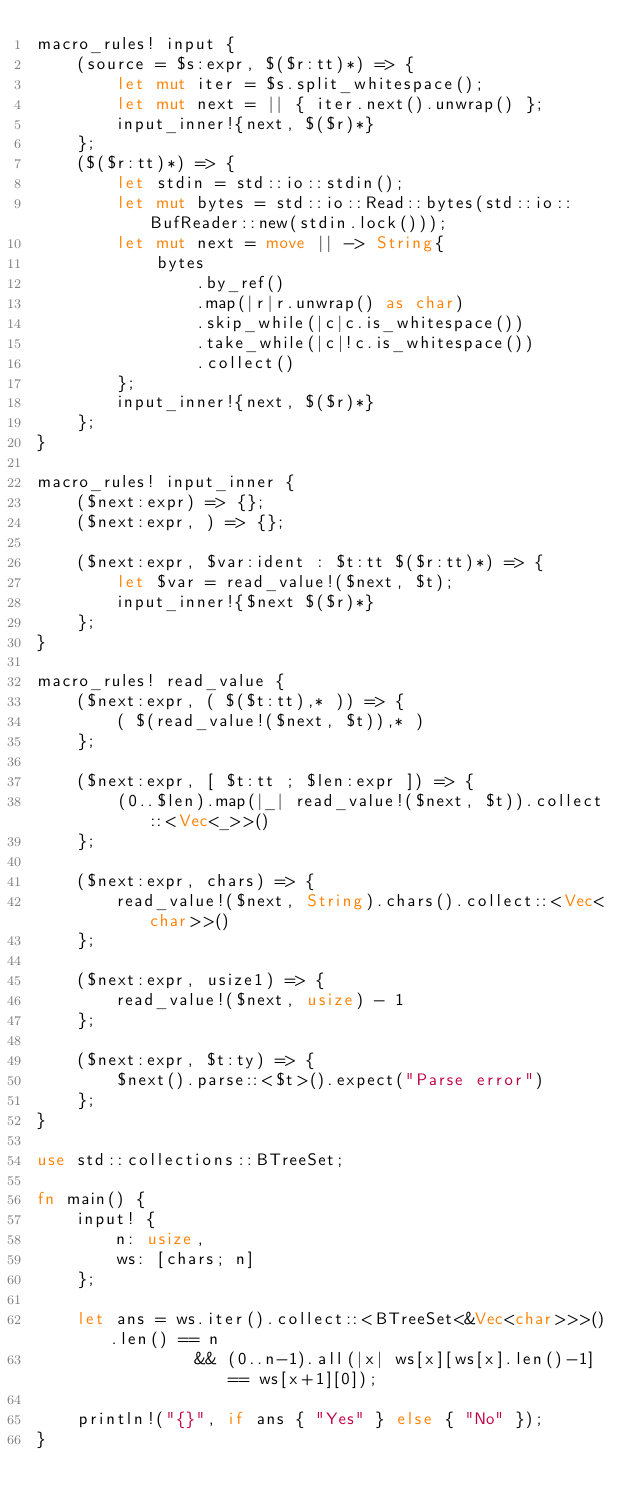<code> <loc_0><loc_0><loc_500><loc_500><_Rust_>macro_rules! input {
    (source = $s:expr, $($r:tt)*) => {
        let mut iter = $s.split_whitespace();
        let mut next = || { iter.next().unwrap() };
        input_inner!{next, $($r)*}
    };
    ($($r:tt)*) => {
        let stdin = std::io::stdin();
        let mut bytes = std::io::Read::bytes(std::io::BufReader::new(stdin.lock()));
        let mut next = move || -> String{
            bytes
                .by_ref()
                .map(|r|r.unwrap() as char)
                .skip_while(|c|c.is_whitespace())
                .take_while(|c|!c.is_whitespace())
                .collect()
        };
        input_inner!{next, $($r)*}
    };
}

macro_rules! input_inner {
    ($next:expr) => {};
    ($next:expr, ) => {};

    ($next:expr, $var:ident : $t:tt $($r:tt)*) => {
        let $var = read_value!($next, $t);
        input_inner!{$next $($r)*}
    };
}

macro_rules! read_value {
    ($next:expr, ( $($t:tt),* )) => {
        ( $(read_value!($next, $t)),* )
    };

    ($next:expr, [ $t:tt ; $len:expr ]) => {
        (0..$len).map(|_| read_value!($next, $t)).collect::<Vec<_>>()
    };

    ($next:expr, chars) => {
        read_value!($next, String).chars().collect::<Vec<char>>()
    };

    ($next:expr, usize1) => {
        read_value!($next, usize) - 1
    };

    ($next:expr, $t:ty) => {
        $next().parse::<$t>().expect("Parse error")
    };
}

use std::collections::BTreeSet;

fn main() {
    input! {
        n: usize,
        ws: [chars; n]
    };

    let ans = ws.iter().collect::<BTreeSet<&Vec<char>>>().len() == n
                && (0..n-1).all(|x| ws[x][ws[x].len()-1] == ws[x+1][0]);

    println!("{}", if ans { "Yes" } else { "No" });
}
</code> 